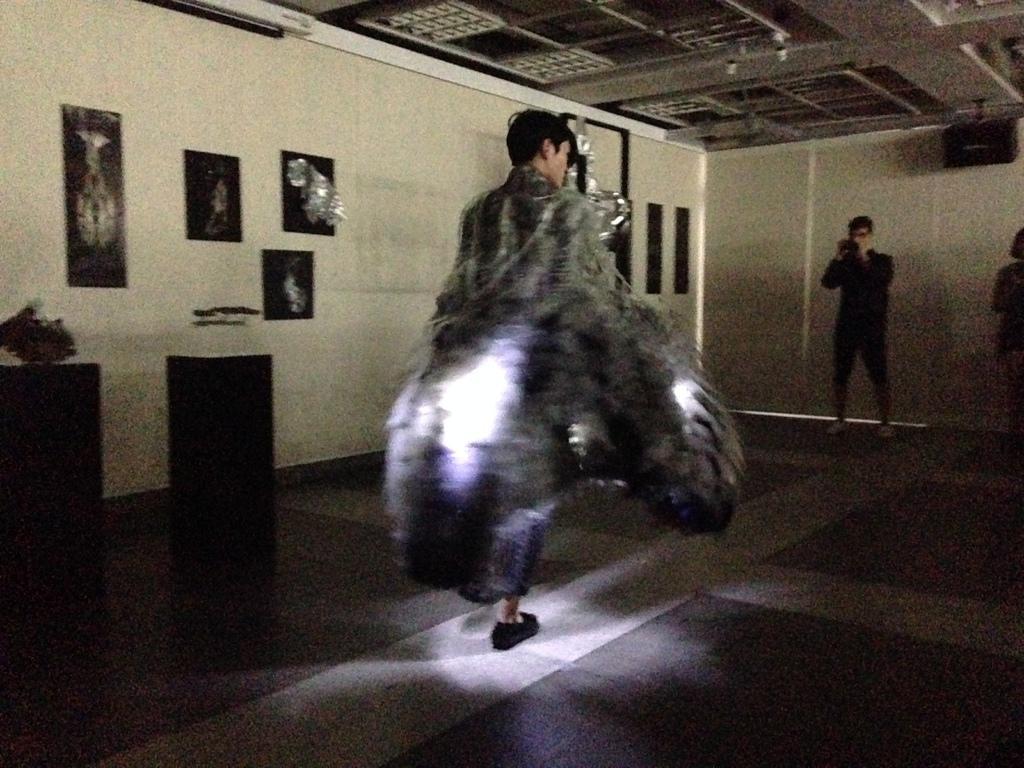Describe this image in one or two sentences. In this image I can see a person wearing a costume is standing on the floor. I can see few lights in his costume. In the background I can see the wall, few photo frames attached to the wall, a person standing and holding an object in his hand, the ceiling and few other objects. 